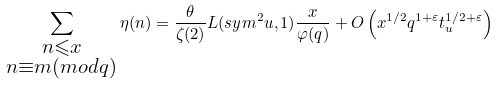Convert formula to latex. <formula><loc_0><loc_0><loc_500><loc_500>\sum _ { \substack { n \leqslant x \\ n \equiv m ( m o d q ) } } \eta ( n ) = \frac { \theta } { \zeta ( 2 ) } L ( s y m ^ { 2 } u , 1 ) \frac { x } { \varphi ( q ) } + O \left ( x ^ { 1 / 2 } q ^ { 1 + \varepsilon } t _ { u } ^ { 1 / 2 + \varepsilon } \right )</formula> 